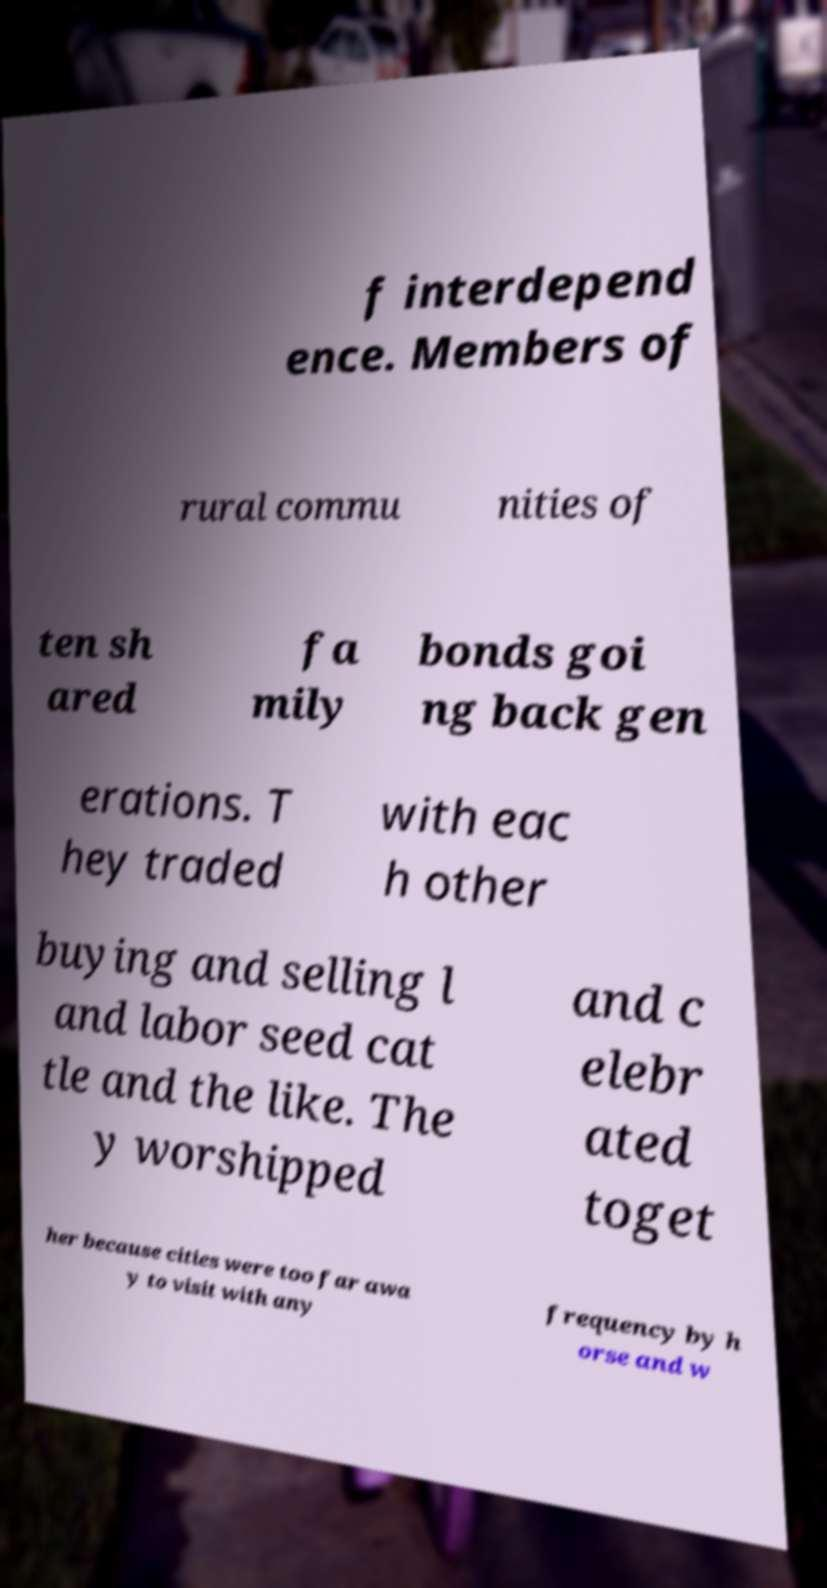Can you read and provide the text displayed in the image?This photo seems to have some interesting text. Can you extract and type it out for me? f interdepend ence. Members of rural commu nities of ten sh ared fa mily bonds goi ng back gen erations. T hey traded with eac h other buying and selling l and labor seed cat tle and the like. The y worshipped and c elebr ated toget her because cities were too far awa y to visit with any frequency by h orse and w 